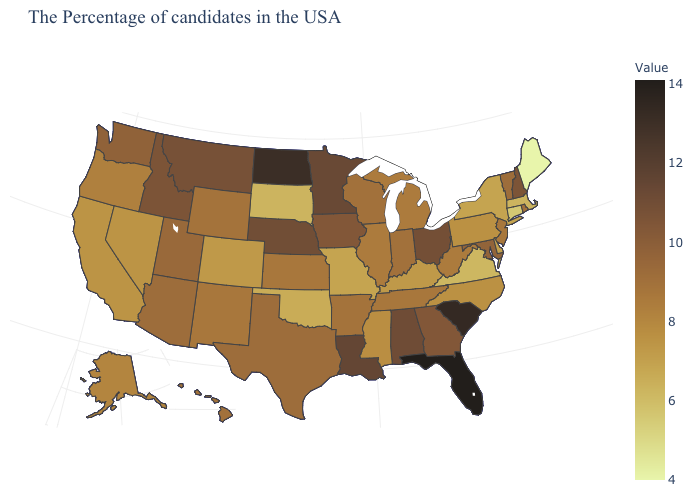Which states have the lowest value in the USA?
Short answer required. Maine. Which states hav the highest value in the Northeast?
Quick response, please. New Hampshire. Does Washington have the lowest value in the USA?
Short answer required. No. 